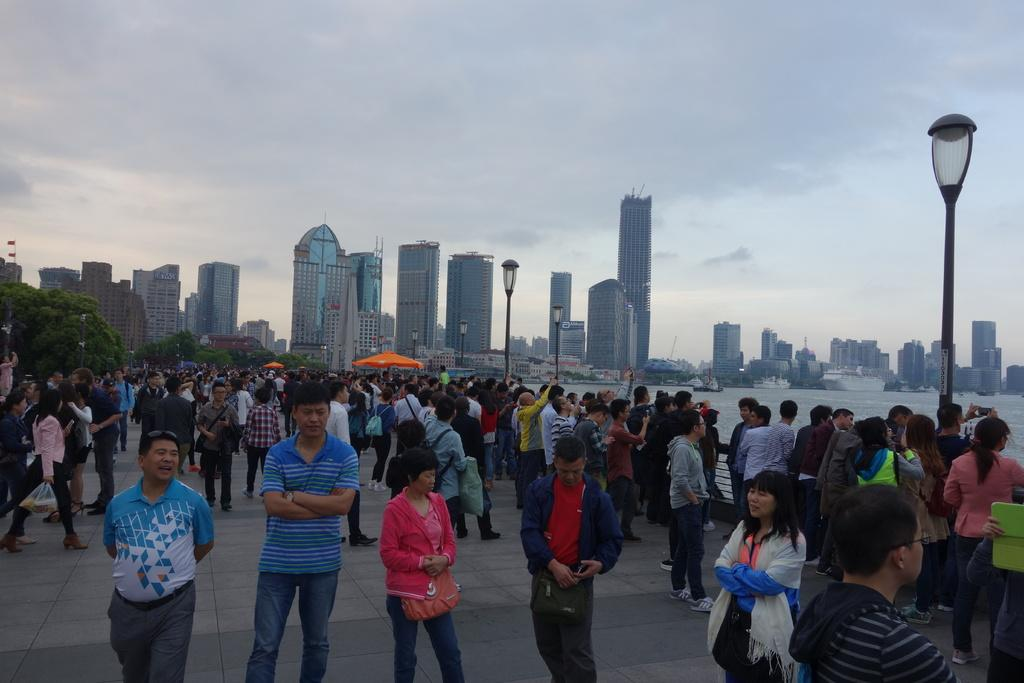What are the people in the image doing? The people in the image are standing on the ground. What can be seen in the distance behind the people? There are buildings, light poles, water, umbrellas, and the sky visible in the background. What year is depicted in the image? The image does not depict a specific year; it is a snapshot of a scene at a particular moment. What type of rake is being used to clean the water in the image? There is no rake present in the image; it features people standing on the ground, buildings, light poles, water, umbrellas, and the sky in the background. 